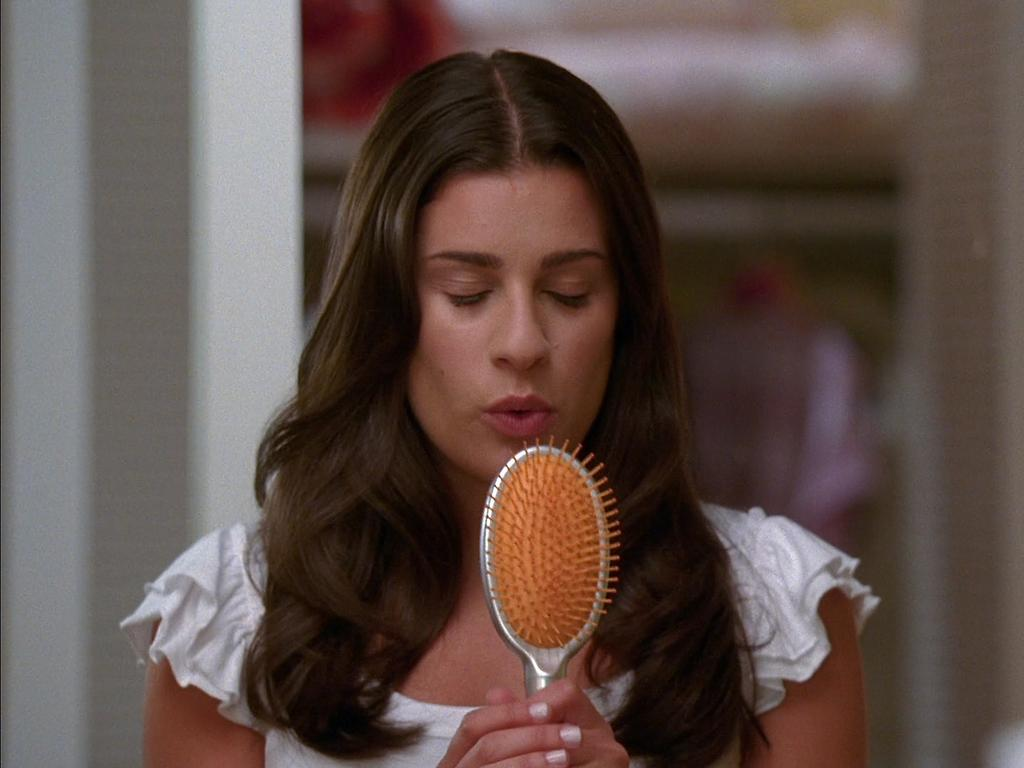Who is the main subject in the image? There is a woman in the image. What is the woman doing in the image? The woman is standing in the image. What object is the woman holding in her hand? The woman is holding a comb in her hand. Can you describe the background of the image? The background of the image is blurry. What type of cat can be seen playing with a level in the image? There is no cat or level present in the image; it features a woman standing and holding a comb. How much oil is visible in the image? There is no oil present in the image. 